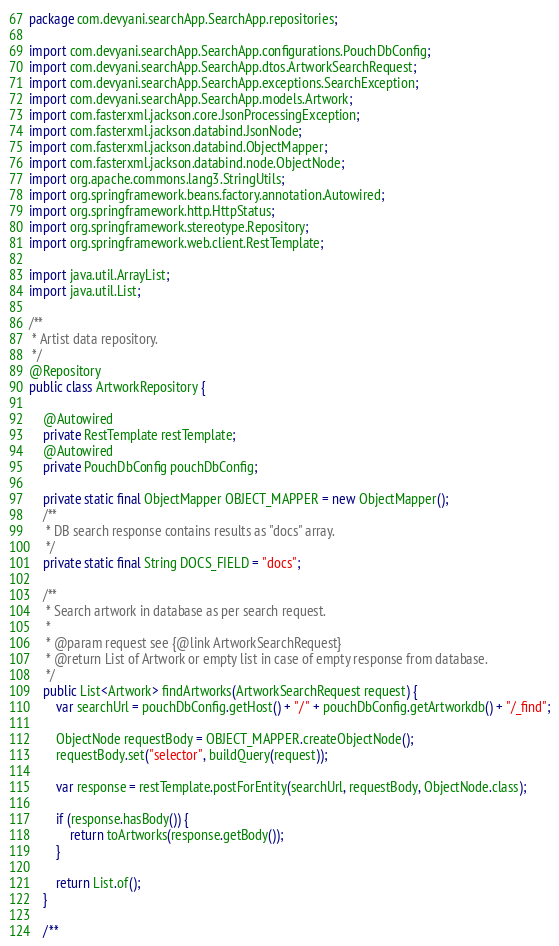Convert code to text. <code><loc_0><loc_0><loc_500><loc_500><_Java_>package com.devyani.searchApp.SearchApp.repositories;

import com.devyani.searchApp.SearchApp.configurations.PouchDbConfig;
import com.devyani.searchApp.SearchApp.dtos.ArtworkSearchRequest;
import com.devyani.searchApp.SearchApp.exceptions.SearchException;
import com.devyani.searchApp.SearchApp.models.Artwork;
import com.fasterxml.jackson.core.JsonProcessingException;
import com.fasterxml.jackson.databind.JsonNode;
import com.fasterxml.jackson.databind.ObjectMapper;
import com.fasterxml.jackson.databind.node.ObjectNode;
import org.apache.commons.lang3.StringUtils;
import org.springframework.beans.factory.annotation.Autowired;
import org.springframework.http.HttpStatus;
import org.springframework.stereotype.Repository;
import org.springframework.web.client.RestTemplate;

import java.util.ArrayList;
import java.util.List;

/**
 * Artist data repository.
 */
@Repository
public class ArtworkRepository {

    @Autowired
    private RestTemplate restTemplate;
    @Autowired
    private PouchDbConfig pouchDbConfig;

    private static final ObjectMapper OBJECT_MAPPER = new ObjectMapper();
    /**
     * DB search response contains results as "docs" array.
     */
    private static final String DOCS_FIELD = "docs";

    /**
     * Search artwork in database as per search request.
     *
     * @param request see {@link ArtworkSearchRequest}
     * @return List of Artwork or empty list in case of empty response from database.
     */
    public List<Artwork> findArtworks(ArtworkSearchRequest request) {
        var searchUrl = pouchDbConfig.getHost() + "/" + pouchDbConfig.getArtworkdb() + "/_find";

        ObjectNode requestBody = OBJECT_MAPPER.createObjectNode();
        requestBody.set("selector", buildQuery(request));

        var response = restTemplate.postForEntity(searchUrl, requestBody, ObjectNode.class);

        if (response.hasBody()) {
            return toArtworks(response.getBody());
        }

        return List.of();
    }

    /**</code> 